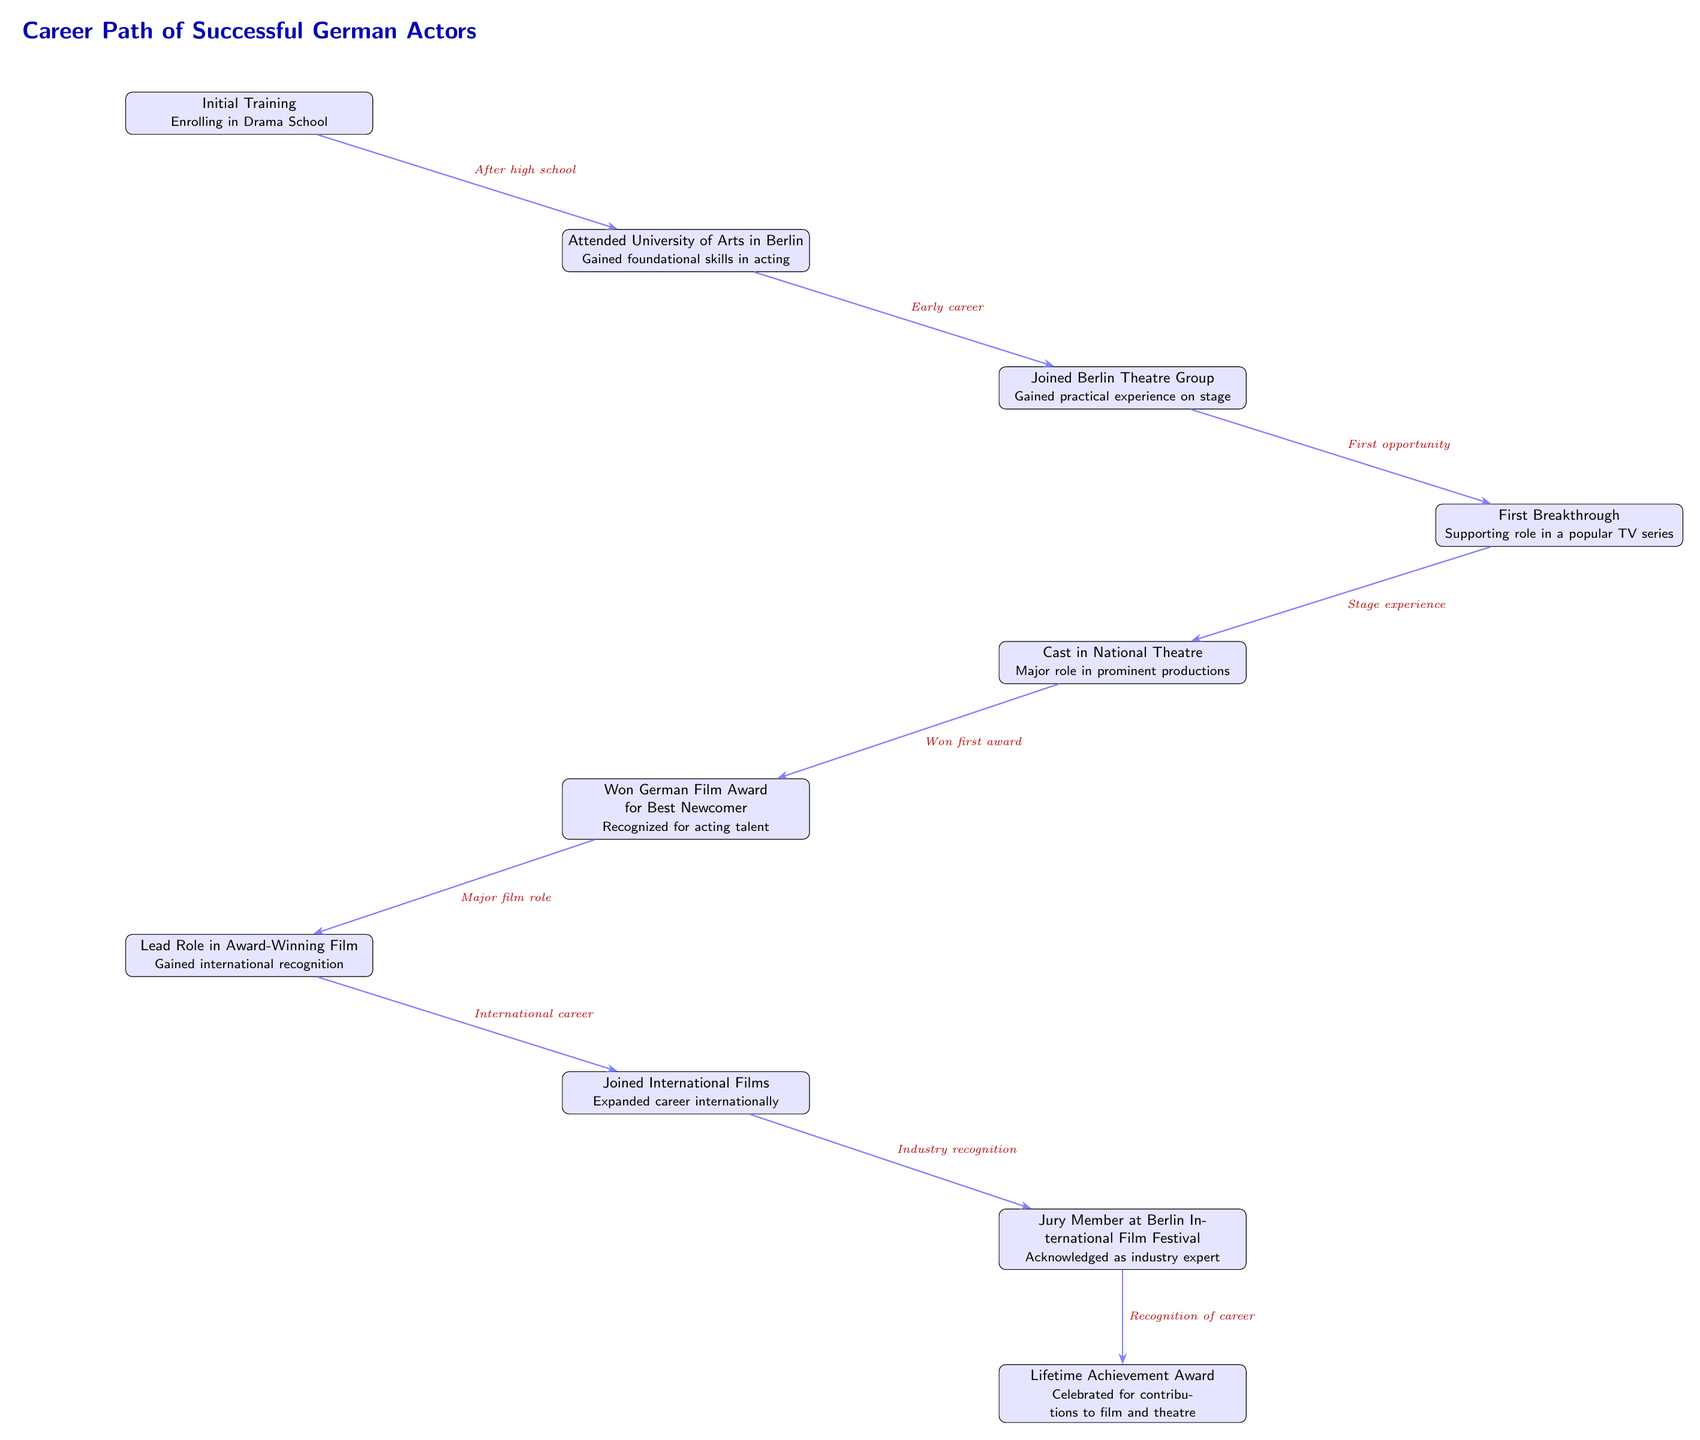What is the first milestone in the career path? The first milestone is "Initial Training," which represents the beginning of an aspiring actor’s journey by enrolling in drama school.
Answer: Initial Training How many nodes are there in the diagram? Counting each distinct step or milestone in the career path, there are a total of nine nodes.
Answer: 9 What role did the actor achieve after joining the Berlin Theatre Group? After joining the Berlin Theatre Group, the actor gained practical experience on stage, as stated in the relevant node.
Answer: Gained practical experience on stage Which milestone follows the "First Breakthrough"? The milestone that follows "First Breakthrough" is "Cast in National Theatre." This milestone indicates the progression from a supporting role to a major role in prominent productions.
Answer: Cast in National Theatre What award did the actor win after their role in a national theatre? After their role in the national theatre, the actor won the "German Film Award for Best Newcomer," recognizing their acting talent.
Answer: German Film Award for Best Newcomer What is the last achievement listed in the diagram? The last achievement listed in the diagram is the "Lifetime Achievement Award," celebrating the actor's contributions to film and theatre over their career.
Answer: Lifetime Achievement Award How does the actor's role in an award-winning film influence their career? The actor’s role in an award-winning film leads to "Gained international recognition," which expands their visibility and opportunities in the film industry on an international scale.
Answer: Gained international recognition What does the arrow between "Lead Role in Award-Winning Film" and "Joined International Films" signify? The arrow signifies a cause-and-effect relationship where the actor's success in an award-winning film facilitates their transition into international films, demonstrating career growth.
Answer: Cause-and-effect relationship What does the diagram indicate about the importance of training in an actor's career? The diagram emphasizes starting with "Initial Training," thereby indicating that foundational skills and training at drama school are crucial for successful progression in an acting career.
Answer: Foundational skills and training are crucial 